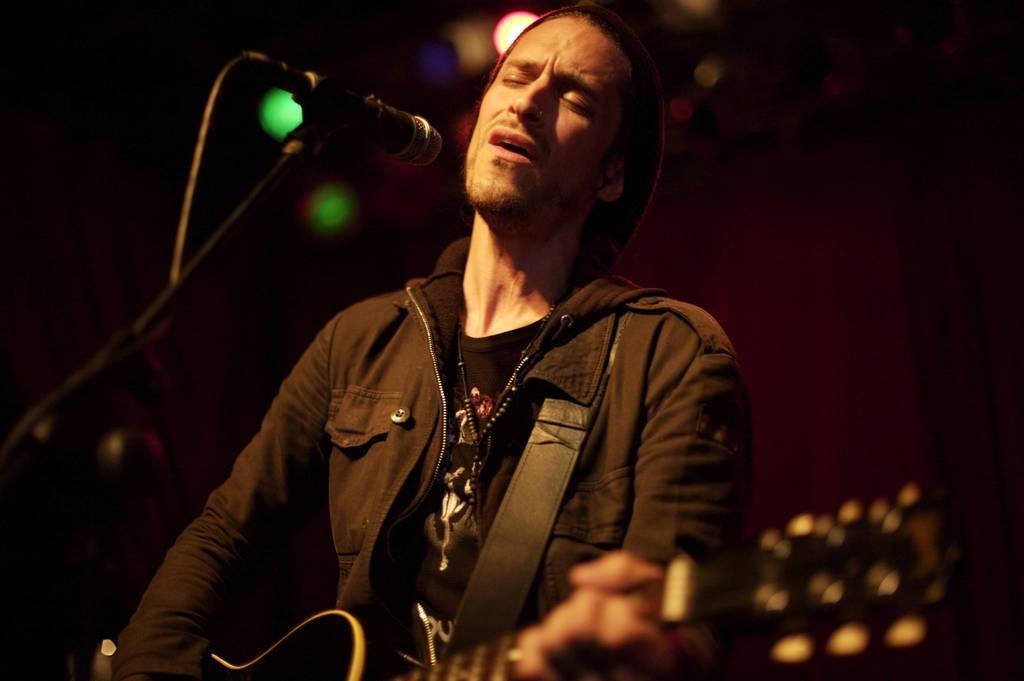Describe this image in one or two sentences. In this image I see a man who is in front of a mic and he is holding a guitar and I see that he is wearing a black jacket. In the background I see the lights. 